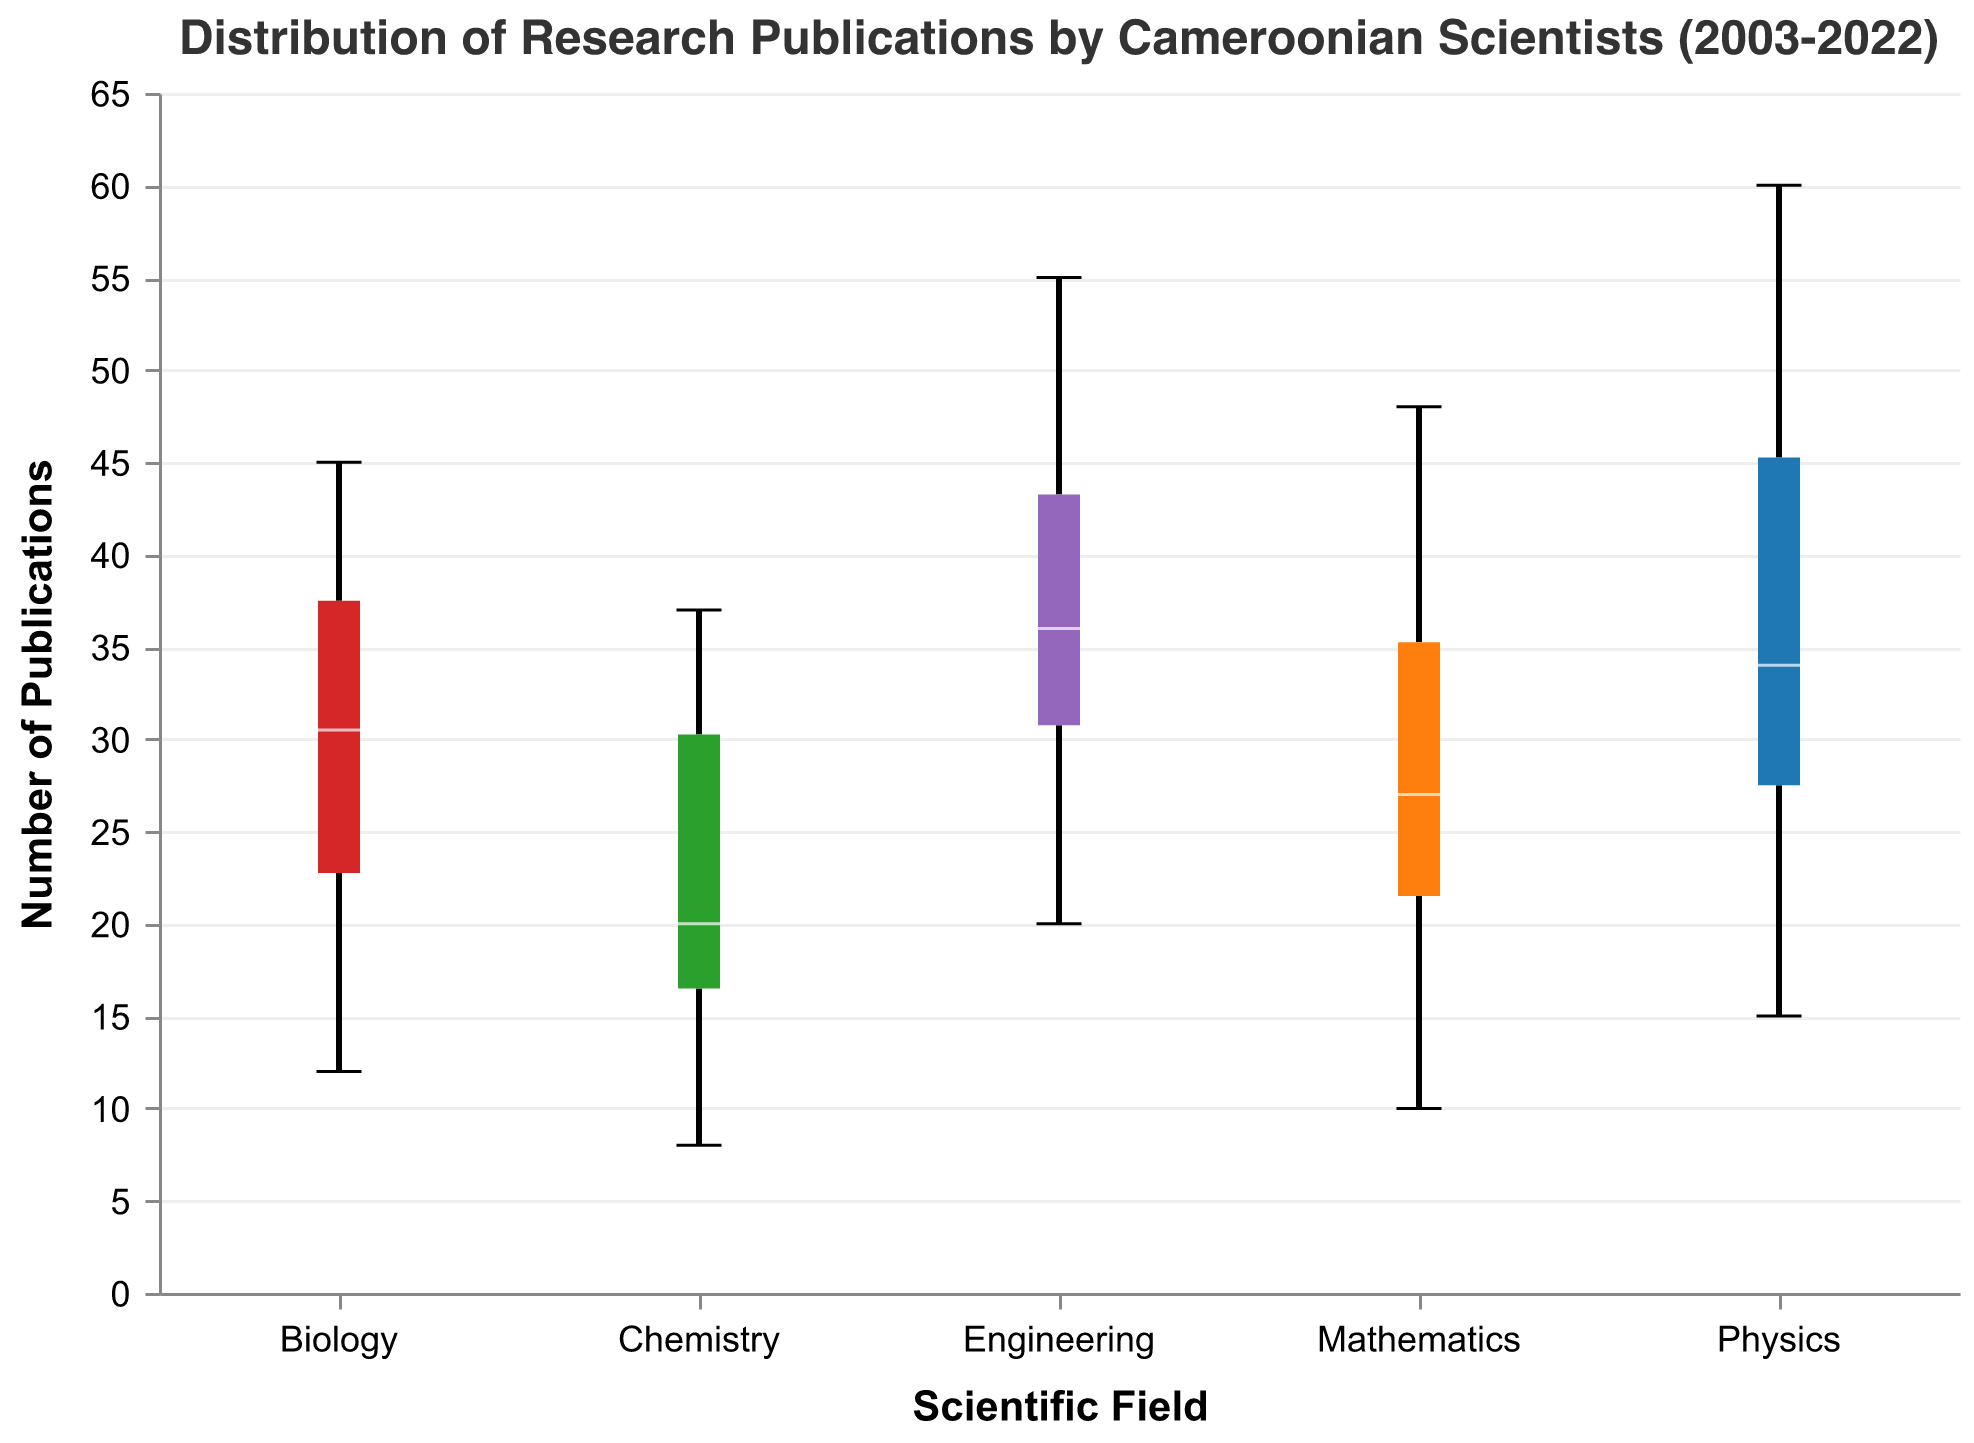What is the title of the figure? The title is provided at the top of the figure. It reads "Distribution of Research Publications by Cameroonian Scientists (2003-2022)."
Answer: Distribution of Research Publications by Cameroonian Scientists (2003-2022) Which scientific field has the widest spread of publication numbers? To find the field with the widest spread, look for the longest whisker or box length. Engineering has the widest spread.
Answer: Engineering Estimate the median number of publications in Chemistry. The median is indicated by a white line in the box. From the figure, the median for Chemistry appears to be 26.
Answer: 26 Between Physics and Mathematics, which field has the higher maximum number of publications? Compare the top whiskers of the Physics and Mathematics notched box plots. Physics has a maximum number of 60 publications, while Mathematics has 48.
Answer: Physics What field shows the highest median number of publications? Compare the positions of the median lines across all fields. Physics has the highest median number of publications.
Answer: Physics Which two fields have the closest median number of publications? Compare the median lines for different fields. Biology and Chemistry have medians that are close to each other.
Answer: Biology and Chemistry What is the range of publication numbers in Biology? The range can be found by subtracting the minimum publication number from the maximum publication number in Biology. The range is 45 - 12 = 33.
Answer: 33 How does the median number of publications in Biology compare to Chemistry? The median lines can be used to compare them. Biology has a slightly higher median compared to Chemistry.
Answer: Biology Which field has the smallest interquartile range (IQR)? The IQR is the width of the box in the notched box plot. Chemistry has the smallest IQR.
Answer: Chemistry How many publications does the upper quartile represent in Mathematics? The upper quartile is the top edge of the box. In Mathematics, it represents about 40 publications.
Answer: 40 